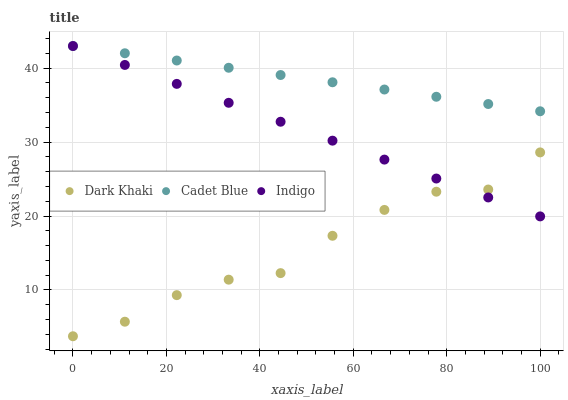Does Dark Khaki have the minimum area under the curve?
Answer yes or no. Yes. Does Cadet Blue have the maximum area under the curve?
Answer yes or no. Yes. Does Indigo have the minimum area under the curve?
Answer yes or no. No. Does Indigo have the maximum area under the curve?
Answer yes or no. No. Is Indigo the smoothest?
Answer yes or no. Yes. Is Dark Khaki the roughest?
Answer yes or no. Yes. Is Cadet Blue the smoothest?
Answer yes or no. No. Is Cadet Blue the roughest?
Answer yes or no. No. Does Dark Khaki have the lowest value?
Answer yes or no. Yes. Does Indigo have the lowest value?
Answer yes or no. No. Does Indigo have the highest value?
Answer yes or no. Yes. Is Dark Khaki less than Cadet Blue?
Answer yes or no. Yes. Is Cadet Blue greater than Dark Khaki?
Answer yes or no. Yes. Does Indigo intersect Cadet Blue?
Answer yes or no. Yes. Is Indigo less than Cadet Blue?
Answer yes or no. No. Is Indigo greater than Cadet Blue?
Answer yes or no. No. Does Dark Khaki intersect Cadet Blue?
Answer yes or no. No. 